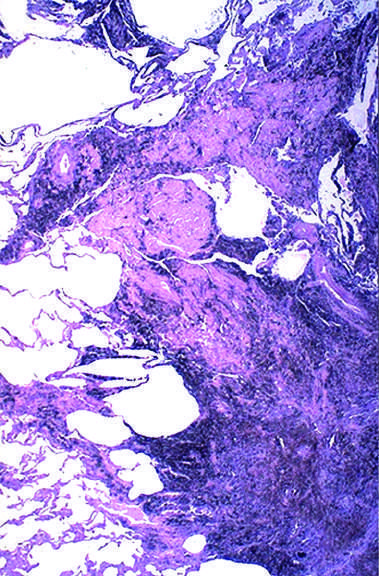what is associated with fibrosis?
Answer the question using a single word or phrase. A large amount of black pigment 